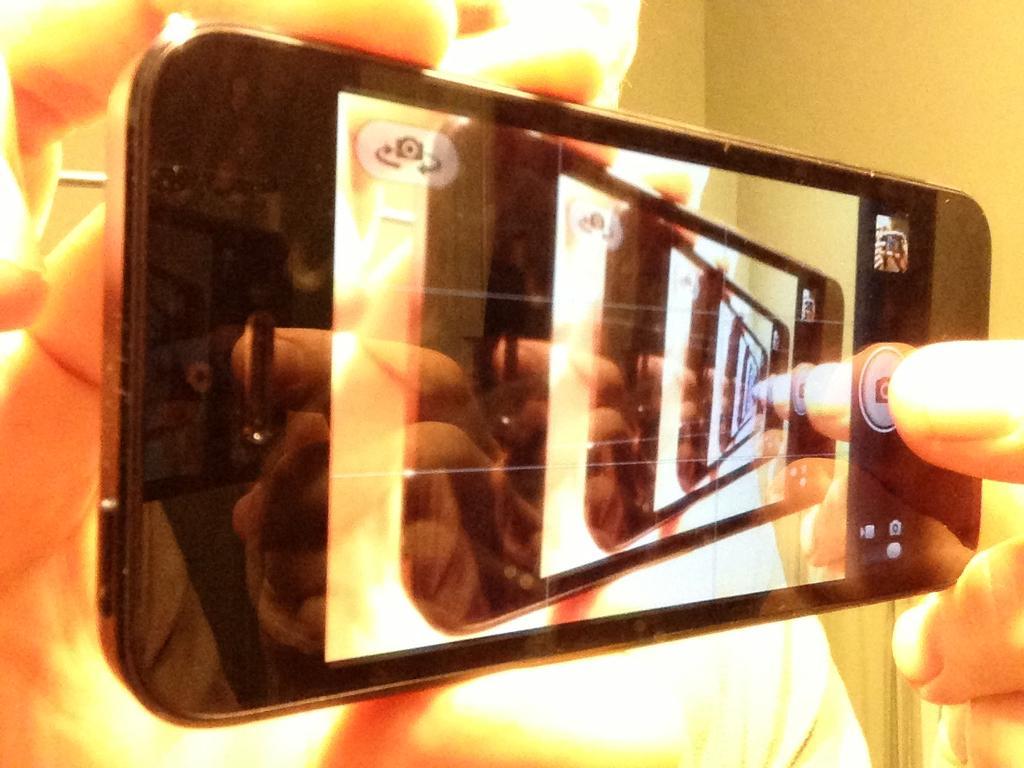Describe this image in one or two sentences. In this image we can see the hands of a person holding a mobile. 